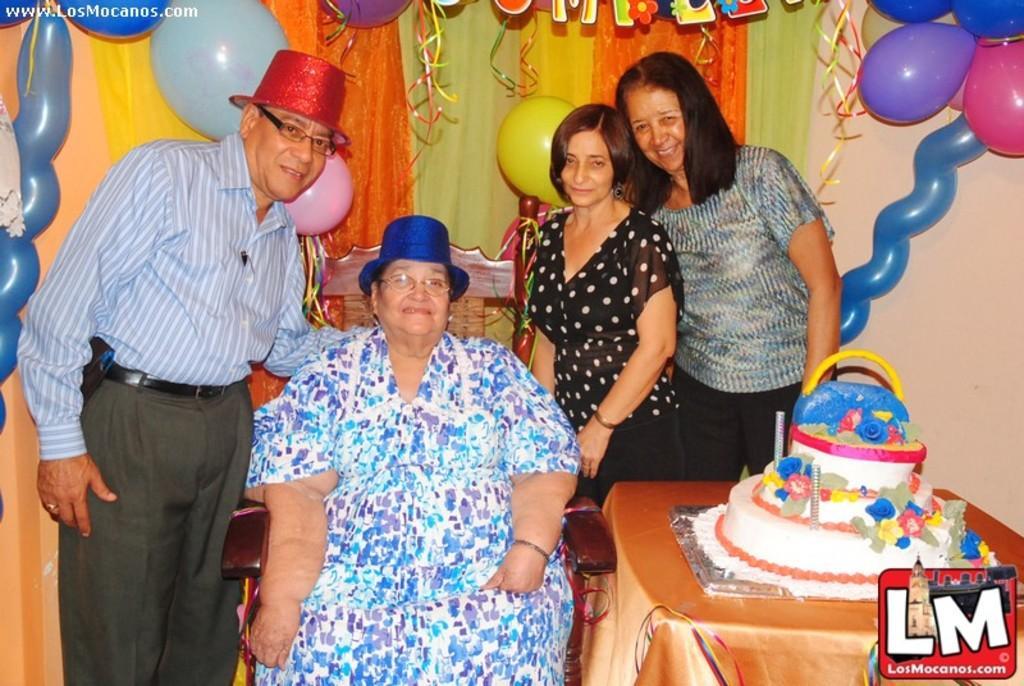Describe this image in one or two sentences. In this image we can see persons sitting on the chair and standing on the floor, cake on the table and decors to the curtain and wall in the background. 